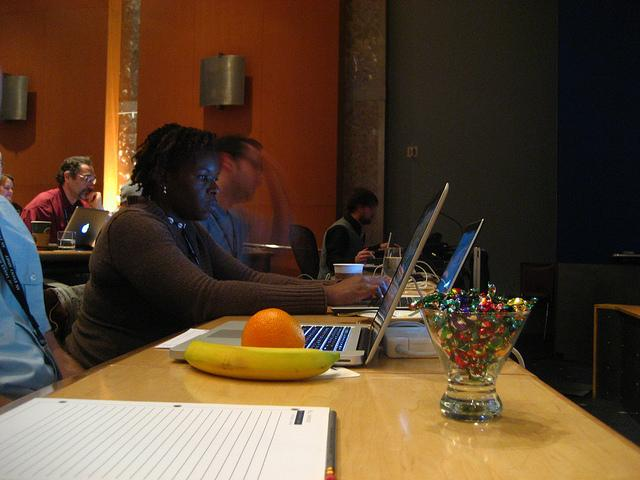Which food is the most unhealthy?

Choices:
A) banana
B) candy
C) coffee
D) orange candy 